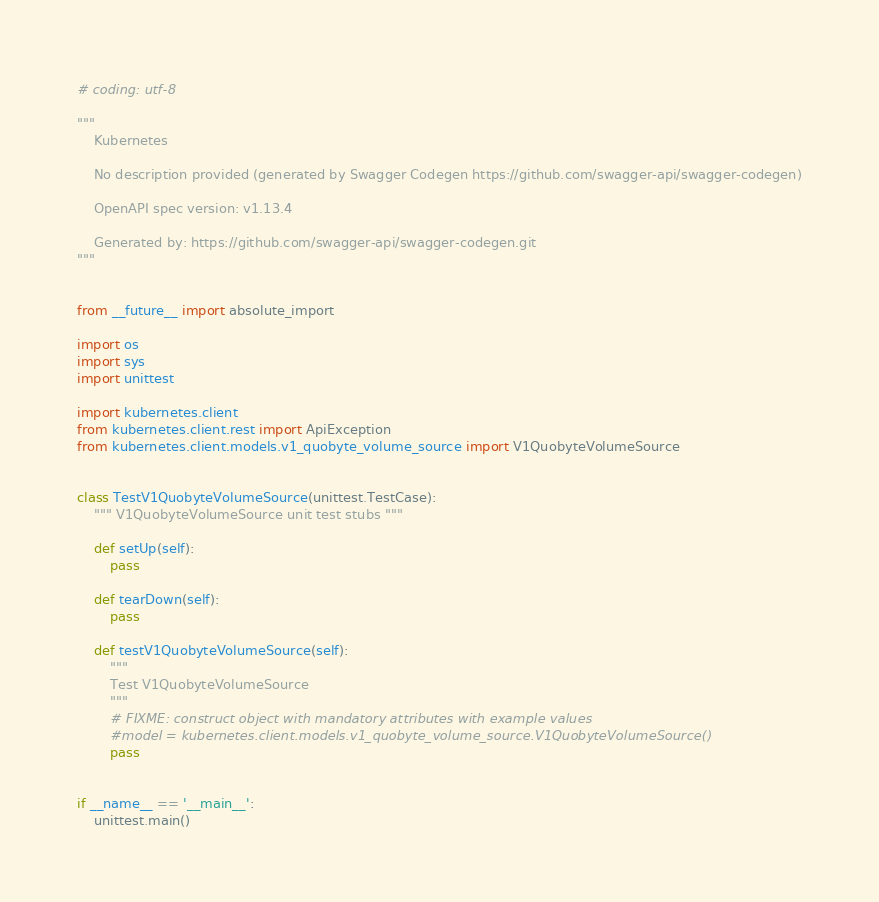<code> <loc_0><loc_0><loc_500><loc_500><_Python_># coding: utf-8

"""
    Kubernetes

    No description provided (generated by Swagger Codegen https://github.com/swagger-api/swagger-codegen)

    OpenAPI spec version: v1.13.4
    
    Generated by: https://github.com/swagger-api/swagger-codegen.git
"""


from __future__ import absolute_import

import os
import sys
import unittest

import kubernetes.client
from kubernetes.client.rest import ApiException
from kubernetes.client.models.v1_quobyte_volume_source import V1QuobyteVolumeSource


class TestV1QuobyteVolumeSource(unittest.TestCase):
    """ V1QuobyteVolumeSource unit test stubs """

    def setUp(self):
        pass

    def tearDown(self):
        pass

    def testV1QuobyteVolumeSource(self):
        """
        Test V1QuobyteVolumeSource
        """
        # FIXME: construct object with mandatory attributes with example values
        #model = kubernetes.client.models.v1_quobyte_volume_source.V1QuobyteVolumeSource()
        pass


if __name__ == '__main__':
    unittest.main()
</code> 